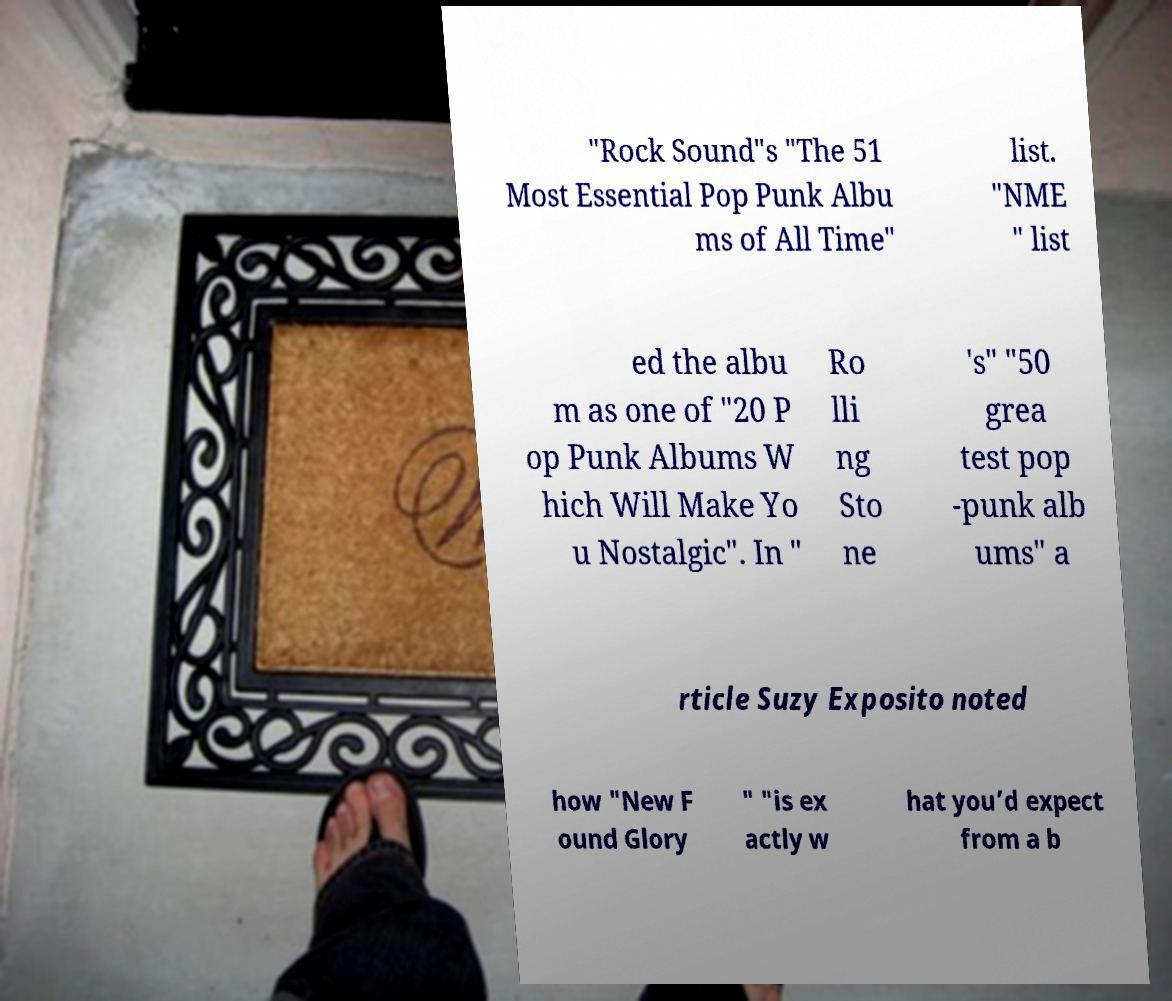Please identify and transcribe the text found in this image. "Rock Sound"s "The 51 Most Essential Pop Punk Albu ms of All Time" list. "NME " list ed the albu m as one of "20 P op Punk Albums W hich Will Make Yo u Nostalgic". In " Ro lli ng Sto ne 's" "50 grea test pop -punk alb ums" a rticle Suzy Exposito noted how "New F ound Glory " "is ex actly w hat you’d expect from a b 